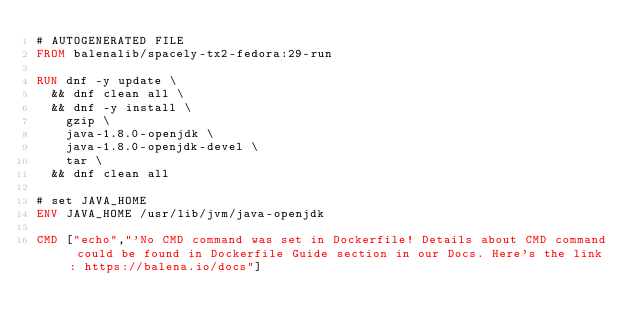Convert code to text. <code><loc_0><loc_0><loc_500><loc_500><_Dockerfile_># AUTOGENERATED FILE
FROM balenalib/spacely-tx2-fedora:29-run

RUN dnf -y update \
	&& dnf clean all \
	&& dnf -y install \
		gzip \
		java-1.8.0-openjdk \
		java-1.8.0-openjdk-devel \
		tar \
	&& dnf clean all

# set JAVA_HOME
ENV JAVA_HOME /usr/lib/jvm/java-openjdk

CMD ["echo","'No CMD command was set in Dockerfile! Details about CMD command could be found in Dockerfile Guide section in our Docs. Here's the link: https://balena.io/docs"]
</code> 